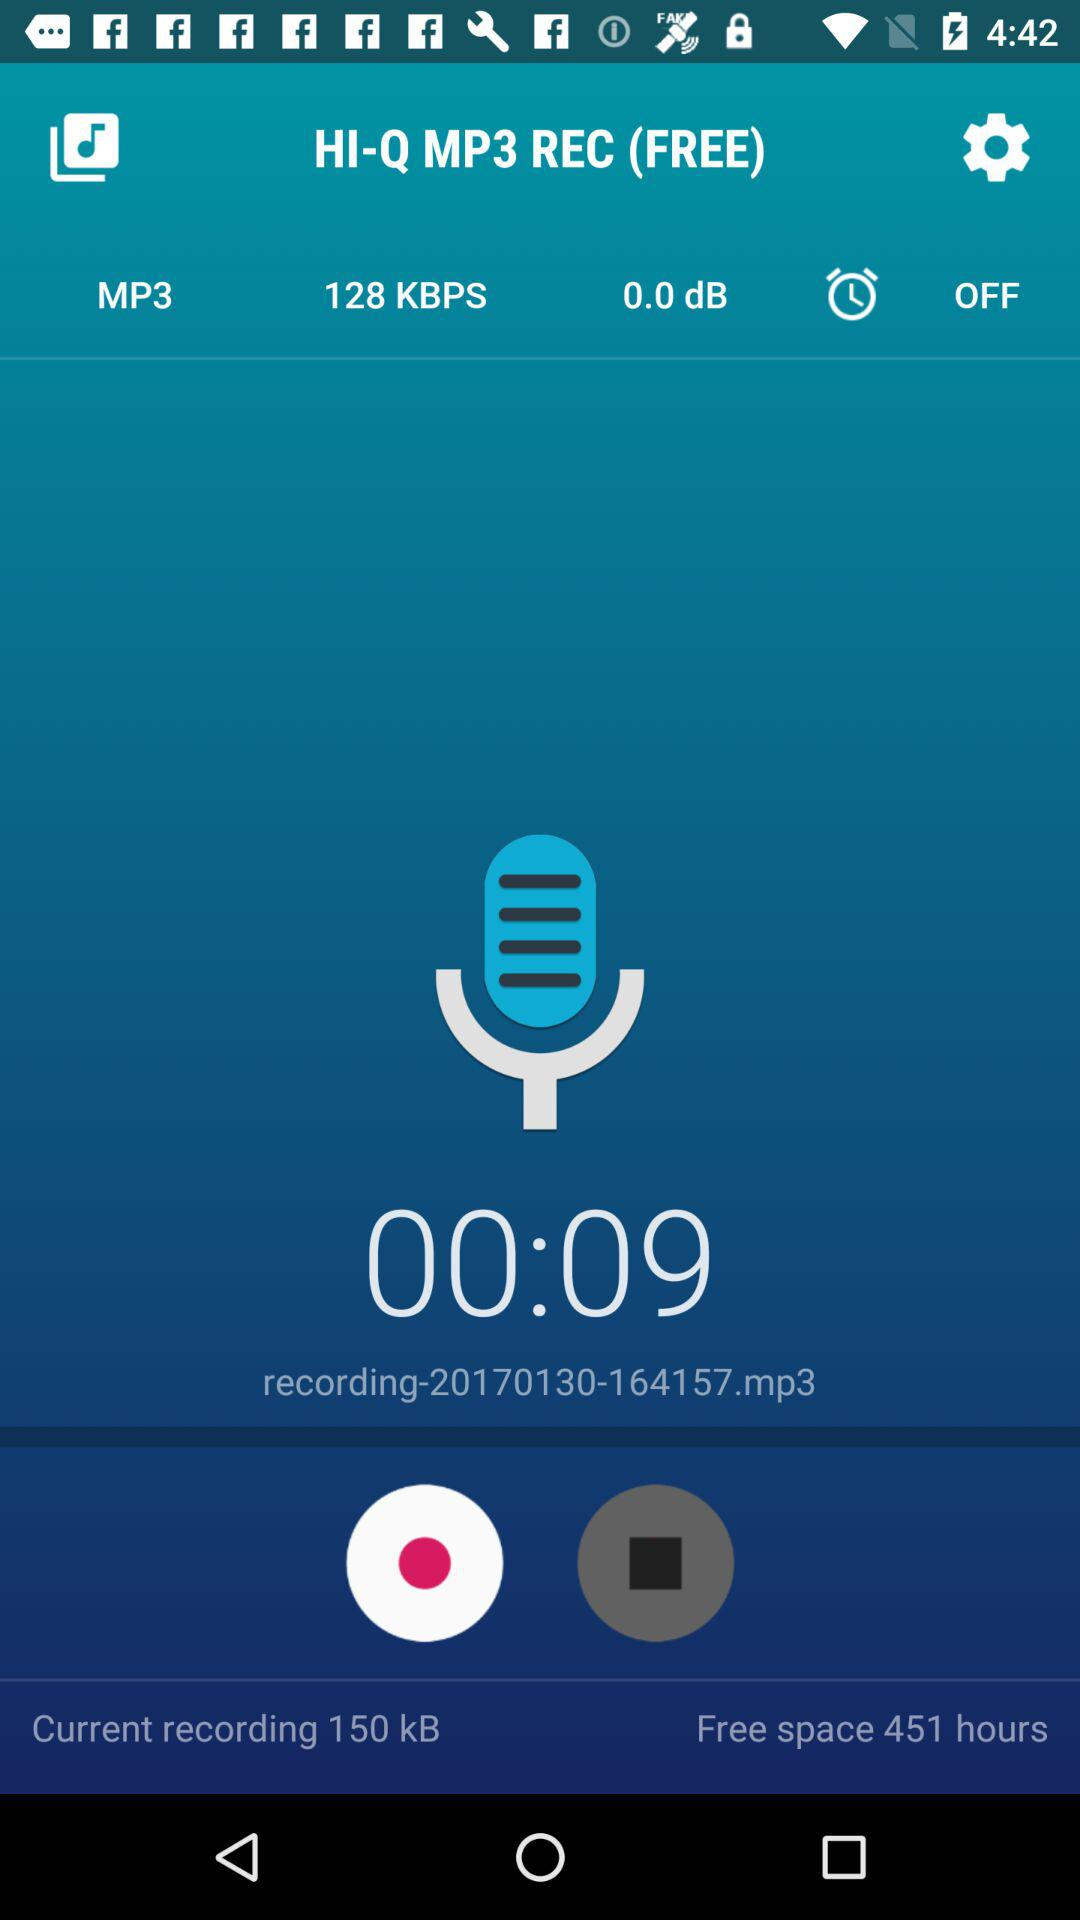What is the total number of free space hours left? The total number of free space hours left is 451. 